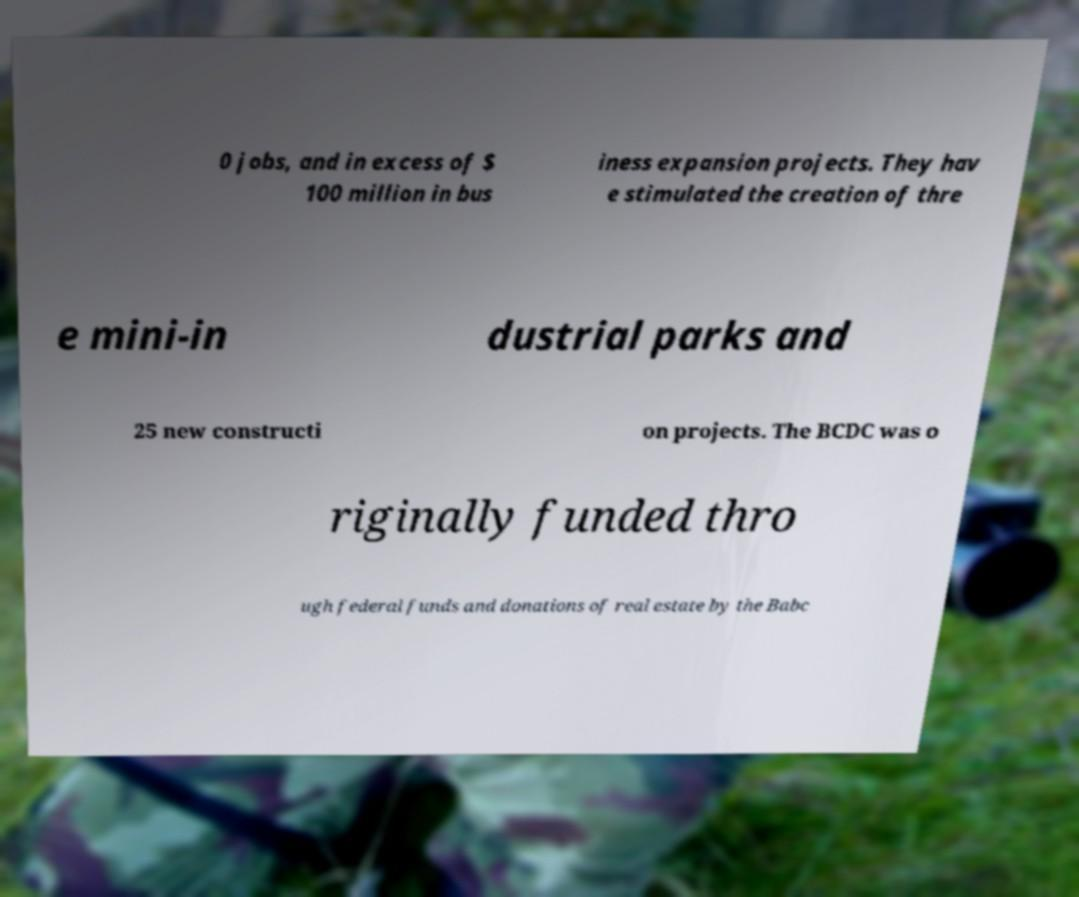I need the written content from this picture converted into text. Can you do that? 0 jobs, and in excess of $ 100 million in bus iness expansion projects. They hav e stimulated the creation of thre e mini-in dustrial parks and 25 new constructi on projects. The BCDC was o riginally funded thro ugh federal funds and donations of real estate by the Babc 